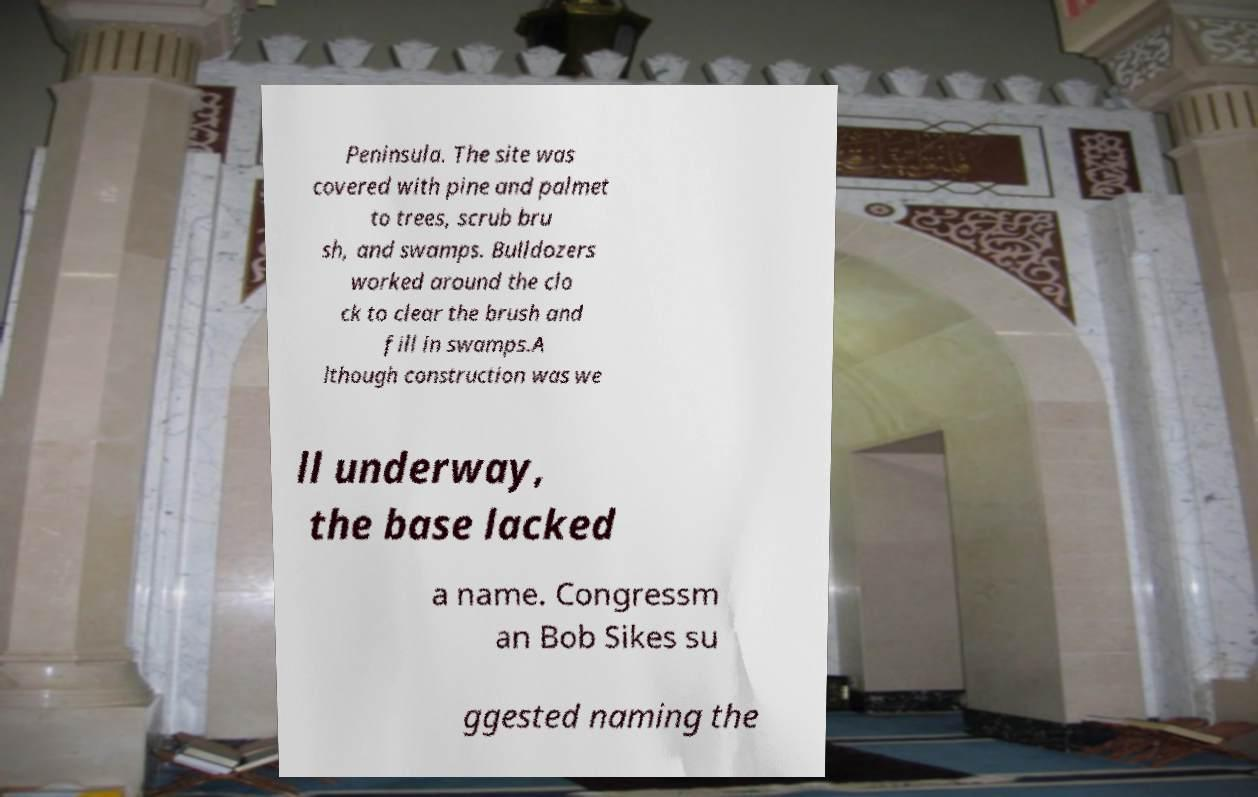Could you assist in decoding the text presented in this image and type it out clearly? Peninsula. The site was covered with pine and palmet to trees, scrub bru sh, and swamps. Bulldozers worked around the clo ck to clear the brush and fill in swamps.A lthough construction was we ll underway, the base lacked a name. Congressm an Bob Sikes su ggested naming the 